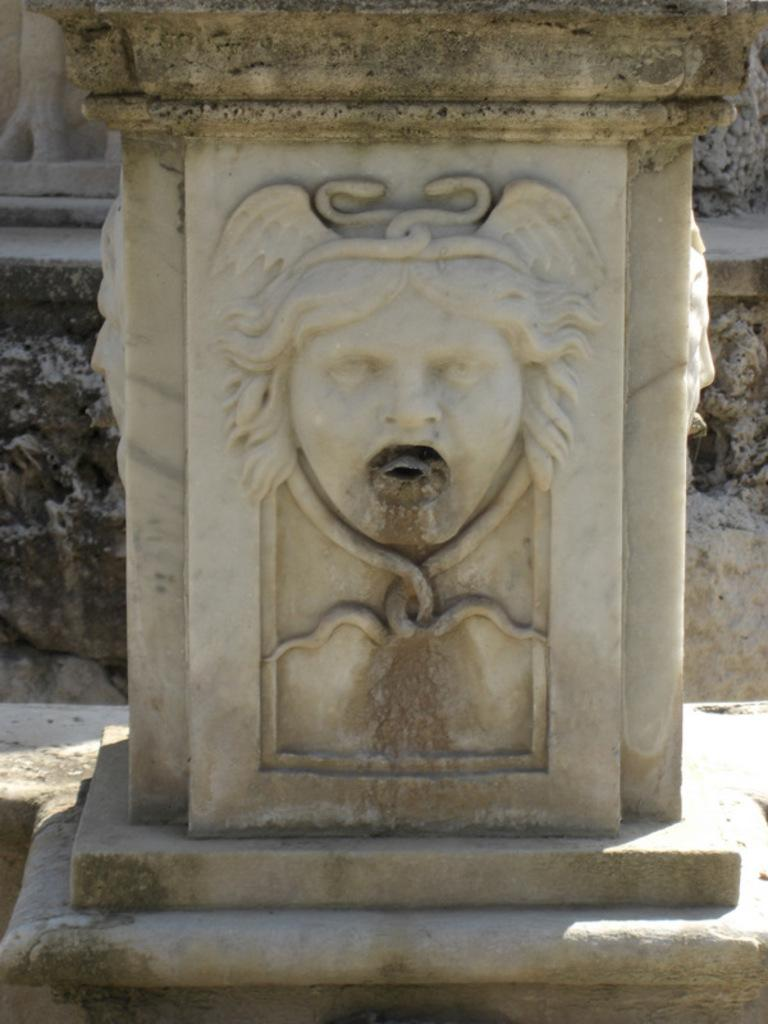What is the main structure in the image? There is a pillar in the image. What color is the pillar? The pillar is white in color. What is on top of the pillar? There is a sculpture on the pillar. How many rings are visible on the pillar in the image? There are no rings visible on the pillar in the image. What type of cake is being served on top of the pillar? There is no cake present on top of the pillar in the image; it has a sculpture instead. 